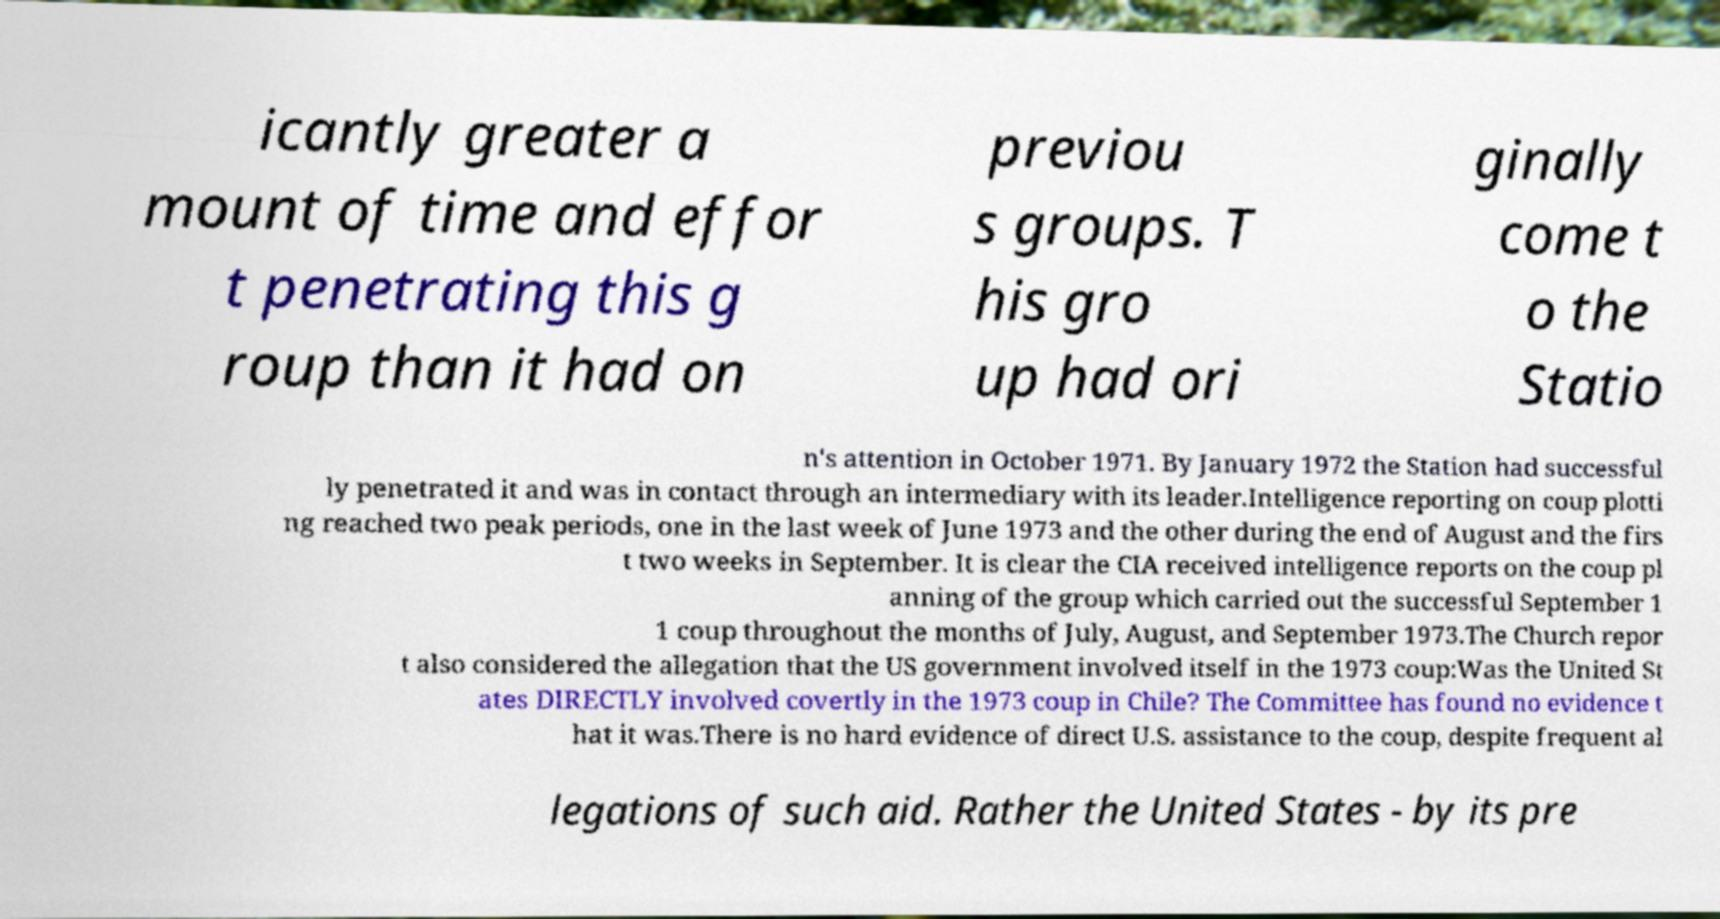I need the written content from this picture converted into text. Can you do that? icantly greater a mount of time and effor t penetrating this g roup than it had on previou s groups. T his gro up had ori ginally come t o the Statio n's attention in October 1971. By January 1972 the Station had successful ly penetrated it and was in contact through an intermediary with its leader.Intelligence reporting on coup plotti ng reached two peak periods, one in the last week of June 1973 and the other during the end of August and the firs t two weeks in September. It is clear the CIA received intelligence reports on the coup pl anning of the group which carried out the successful September 1 1 coup throughout the months of July, August, and September 1973.The Church repor t also considered the allegation that the US government involved itself in the 1973 coup:Was the United St ates DIRECTLY involved covertly in the 1973 coup in Chile? The Committee has found no evidence t hat it was.There is no hard evidence of direct U.S. assistance to the coup, despite frequent al legations of such aid. Rather the United States - by its pre 